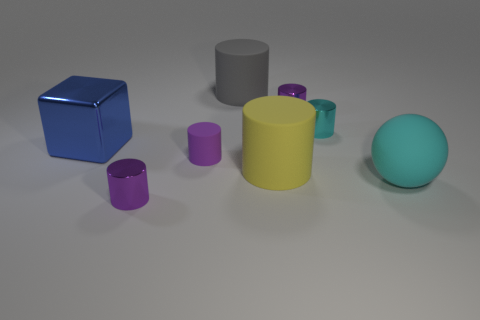Subtract all big gray cylinders. How many cylinders are left? 5 Subtract all gray spheres. How many purple cylinders are left? 3 Subtract all cyan cylinders. How many cylinders are left? 5 Subtract 4 cylinders. How many cylinders are left? 2 Add 2 gray cylinders. How many objects exist? 10 Subtract all red cylinders. Subtract all green balls. How many cylinders are left? 6 Subtract all balls. How many objects are left? 7 Add 7 tiny purple matte objects. How many tiny purple matte objects exist? 8 Subtract 2 purple cylinders. How many objects are left? 6 Subtract all big blue shiny cubes. Subtract all big yellow objects. How many objects are left? 6 